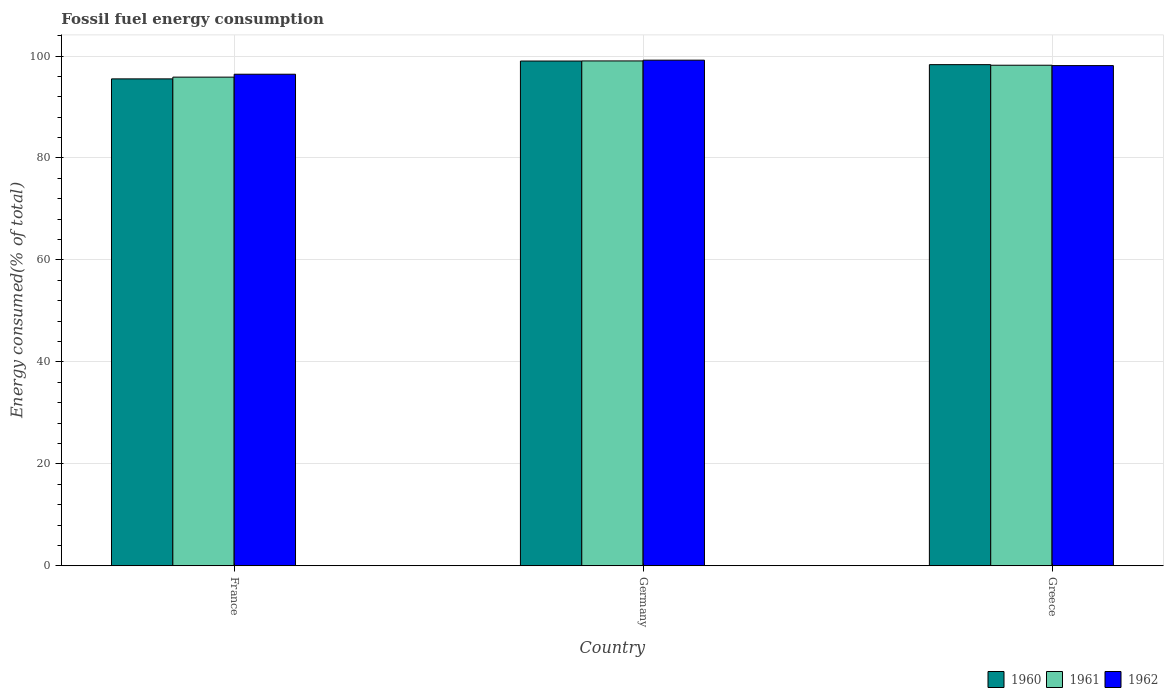How many bars are there on the 1st tick from the left?
Keep it short and to the point. 3. What is the percentage of energy consumed in 1960 in Germany?
Provide a succinct answer. 99.02. Across all countries, what is the maximum percentage of energy consumed in 1962?
Provide a succinct answer. 99.19. Across all countries, what is the minimum percentage of energy consumed in 1960?
Your response must be concise. 95.52. In which country was the percentage of energy consumed in 1960 minimum?
Keep it short and to the point. France. What is the total percentage of energy consumed in 1962 in the graph?
Keep it short and to the point. 293.75. What is the difference between the percentage of energy consumed in 1962 in Germany and that in Greece?
Make the answer very short. 1.07. What is the difference between the percentage of energy consumed in 1961 in Germany and the percentage of energy consumed in 1960 in France?
Ensure brevity in your answer.  3.52. What is the average percentage of energy consumed in 1960 per country?
Provide a succinct answer. 97.62. What is the difference between the percentage of energy consumed of/in 1961 and percentage of energy consumed of/in 1960 in France?
Provide a short and direct response. 0.34. What is the ratio of the percentage of energy consumed in 1960 in Germany to that in Greece?
Ensure brevity in your answer.  1.01. Is the percentage of energy consumed in 1961 in Germany less than that in Greece?
Offer a very short reply. No. Is the difference between the percentage of energy consumed in 1961 in Germany and Greece greater than the difference between the percentage of energy consumed in 1960 in Germany and Greece?
Ensure brevity in your answer.  Yes. What is the difference between the highest and the second highest percentage of energy consumed in 1962?
Ensure brevity in your answer.  -1.69. What is the difference between the highest and the lowest percentage of energy consumed in 1961?
Your answer should be compact. 3.18. In how many countries, is the percentage of energy consumed in 1960 greater than the average percentage of energy consumed in 1960 taken over all countries?
Your response must be concise. 2. Is the sum of the percentage of energy consumed in 1960 in France and Germany greater than the maximum percentage of energy consumed in 1962 across all countries?
Your response must be concise. Yes. What does the 3rd bar from the left in Germany represents?
Offer a terse response. 1962. Is it the case that in every country, the sum of the percentage of energy consumed in 1960 and percentage of energy consumed in 1962 is greater than the percentage of energy consumed in 1961?
Ensure brevity in your answer.  Yes. How many bars are there?
Give a very brief answer. 9. How many countries are there in the graph?
Your answer should be compact. 3. How are the legend labels stacked?
Make the answer very short. Horizontal. What is the title of the graph?
Your response must be concise. Fossil fuel energy consumption. What is the label or title of the Y-axis?
Keep it short and to the point. Energy consumed(% of total). What is the Energy consumed(% of total) of 1960 in France?
Provide a short and direct response. 95.52. What is the Energy consumed(% of total) in 1961 in France?
Give a very brief answer. 95.86. What is the Energy consumed(% of total) of 1962 in France?
Keep it short and to the point. 96.43. What is the Energy consumed(% of total) of 1960 in Germany?
Provide a succinct answer. 99.02. What is the Energy consumed(% of total) of 1961 in Germany?
Your response must be concise. 99.04. What is the Energy consumed(% of total) of 1962 in Germany?
Offer a terse response. 99.19. What is the Energy consumed(% of total) in 1960 in Greece?
Provide a succinct answer. 98.31. What is the Energy consumed(% of total) in 1961 in Greece?
Your response must be concise. 98.2. What is the Energy consumed(% of total) of 1962 in Greece?
Provide a succinct answer. 98.12. Across all countries, what is the maximum Energy consumed(% of total) of 1960?
Your answer should be compact. 99.02. Across all countries, what is the maximum Energy consumed(% of total) of 1961?
Give a very brief answer. 99.04. Across all countries, what is the maximum Energy consumed(% of total) in 1962?
Offer a terse response. 99.19. Across all countries, what is the minimum Energy consumed(% of total) in 1960?
Offer a terse response. 95.52. Across all countries, what is the minimum Energy consumed(% of total) of 1961?
Your answer should be very brief. 95.86. Across all countries, what is the minimum Energy consumed(% of total) of 1962?
Provide a succinct answer. 96.43. What is the total Energy consumed(% of total) in 1960 in the graph?
Provide a succinct answer. 292.85. What is the total Energy consumed(% of total) in 1961 in the graph?
Offer a terse response. 293.1. What is the total Energy consumed(% of total) in 1962 in the graph?
Provide a succinct answer. 293.75. What is the difference between the Energy consumed(% of total) of 1960 in France and that in Germany?
Provide a succinct answer. -3.5. What is the difference between the Energy consumed(% of total) of 1961 in France and that in Germany?
Make the answer very short. -3.18. What is the difference between the Energy consumed(% of total) in 1962 in France and that in Germany?
Offer a terse response. -2.76. What is the difference between the Energy consumed(% of total) of 1960 in France and that in Greece?
Provide a short and direct response. -2.79. What is the difference between the Energy consumed(% of total) of 1961 in France and that in Greece?
Your answer should be compact. -2.34. What is the difference between the Energy consumed(% of total) in 1962 in France and that in Greece?
Offer a terse response. -1.69. What is the difference between the Energy consumed(% of total) in 1960 in Germany and that in Greece?
Your answer should be compact. 0.71. What is the difference between the Energy consumed(% of total) in 1961 in Germany and that in Greece?
Provide a short and direct response. 0.84. What is the difference between the Energy consumed(% of total) in 1962 in Germany and that in Greece?
Keep it short and to the point. 1.07. What is the difference between the Energy consumed(% of total) in 1960 in France and the Energy consumed(% of total) in 1961 in Germany?
Your answer should be very brief. -3.52. What is the difference between the Energy consumed(% of total) in 1960 in France and the Energy consumed(% of total) in 1962 in Germany?
Your response must be concise. -3.67. What is the difference between the Energy consumed(% of total) in 1961 in France and the Energy consumed(% of total) in 1962 in Germany?
Your answer should be very brief. -3.33. What is the difference between the Energy consumed(% of total) in 1960 in France and the Energy consumed(% of total) in 1961 in Greece?
Offer a terse response. -2.68. What is the difference between the Energy consumed(% of total) in 1960 in France and the Energy consumed(% of total) in 1962 in Greece?
Offer a terse response. -2.6. What is the difference between the Energy consumed(% of total) in 1961 in France and the Energy consumed(% of total) in 1962 in Greece?
Keep it short and to the point. -2.26. What is the difference between the Energy consumed(% of total) in 1960 in Germany and the Energy consumed(% of total) in 1961 in Greece?
Ensure brevity in your answer.  0.82. What is the difference between the Energy consumed(% of total) in 1960 in Germany and the Energy consumed(% of total) in 1962 in Greece?
Offer a very short reply. 0.9. What is the difference between the Energy consumed(% of total) of 1961 in Germany and the Energy consumed(% of total) of 1962 in Greece?
Provide a succinct answer. 0.92. What is the average Energy consumed(% of total) in 1960 per country?
Your answer should be compact. 97.62. What is the average Energy consumed(% of total) in 1961 per country?
Your answer should be compact. 97.7. What is the average Energy consumed(% of total) of 1962 per country?
Offer a very short reply. 97.92. What is the difference between the Energy consumed(% of total) of 1960 and Energy consumed(% of total) of 1961 in France?
Keep it short and to the point. -0.34. What is the difference between the Energy consumed(% of total) of 1960 and Energy consumed(% of total) of 1962 in France?
Your answer should be compact. -0.91. What is the difference between the Energy consumed(% of total) in 1961 and Energy consumed(% of total) in 1962 in France?
Provide a short and direct response. -0.57. What is the difference between the Energy consumed(% of total) of 1960 and Energy consumed(% of total) of 1961 in Germany?
Your answer should be very brief. -0.02. What is the difference between the Energy consumed(% of total) in 1960 and Energy consumed(% of total) in 1962 in Germany?
Provide a short and direct response. -0.17. What is the difference between the Energy consumed(% of total) of 1961 and Energy consumed(% of total) of 1962 in Germany?
Ensure brevity in your answer.  -0.15. What is the difference between the Energy consumed(% of total) of 1960 and Energy consumed(% of total) of 1961 in Greece?
Keep it short and to the point. 0.11. What is the difference between the Energy consumed(% of total) in 1960 and Energy consumed(% of total) in 1962 in Greece?
Offer a very short reply. 0.19. What is the difference between the Energy consumed(% of total) in 1961 and Energy consumed(% of total) in 1962 in Greece?
Your answer should be very brief. 0.07. What is the ratio of the Energy consumed(% of total) in 1960 in France to that in Germany?
Ensure brevity in your answer.  0.96. What is the ratio of the Energy consumed(% of total) in 1961 in France to that in Germany?
Ensure brevity in your answer.  0.97. What is the ratio of the Energy consumed(% of total) in 1962 in France to that in Germany?
Your answer should be compact. 0.97. What is the ratio of the Energy consumed(% of total) in 1960 in France to that in Greece?
Offer a very short reply. 0.97. What is the ratio of the Energy consumed(% of total) in 1961 in France to that in Greece?
Offer a very short reply. 0.98. What is the ratio of the Energy consumed(% of total) in 1962 in France to that in Greece?
Offer a terse response. 0.98. What is the ratio of the Energy consumed(% of total) in 1961 in Germany to that in Greece?
Keep it short and to the point. 1.01. What is the ratio of the Energy consumed(% of total) in 1962 in Germany to that in Greece?
Offer a terse response. 1.01. What is the difference between the highest and the second highest Energy consumed(% of total) in 1960?
Your answer should be very brief. 0.71. What is the difference between the highest and the second highest Energy consumed(% of total) of 1961?
Give a very brief answer. 0.84. What is the difference between the highest and the second highest Energy consumed(% of total) of 1962?
Keep it short and to the point. 1.07. What is the difference between the highest and the lowest Energy consumed(% of total) of 1960?
Provide a succinct answer. 3.5. What is the difference between the highest and the lowest Energy consumed(% of total) of 1961?
Provide a succinct answer. 3.18. What is the difference between the highest and the lowest Energy consumed(% of total) in 1962?
Make the answer very short. 2.76. 